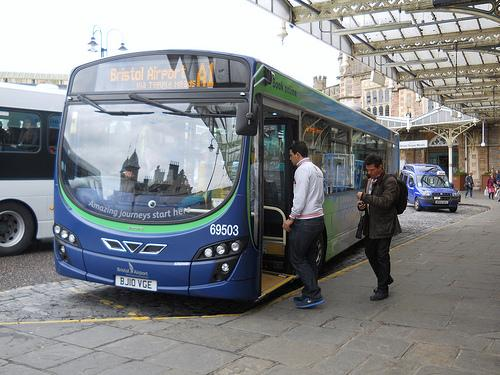Provide an appraisal of the mood or atmosphere portrayed in the image. The image conveys a calm and everyday atmosphere, with the man waiting for the bus and the surrounding environment contributing to a typical city scene. State one specific piece of information related to the bus's destination. The bus is going to the airport. What clothing items can be identified on the man in the image? The man is wearing a brown jacket, blue jeans, white sweater, and sneakers. Describe any infrastructure-related items that can be found in the image. A sidewalk, window of a building, part of a lamp light, and a road are all present in the image. What are the features of the man's sneakers in the image? The man's sneakers are blue and black in color. Express the colors and sizes of the bus shown in the image. The image shows a long blue and green bus. Enumerate any vehicles present behind the bus and their colors. There is a blue car and a blue van behind the bus. Mention a prominent feature found on the bus in the image. The bus has four lights on the front and an open door. What activity does the man seem to be involved in, based on his attire and surrounding environment? The man appears to be waiting for the bus, as he is dressed in a jacket, jeans, and sneakers, and standing near a bus. Are the trees behind the bus green and tall? No trees are described in any of the existing captions. Can you see the yellow bicycle parked next to the bus? None of the captions mention a bicycle or yellow color. Does the man have an umbrella in his hand? No existing caption mentions an umbrella or the man holding anything. Are there people standing inside the open door of the bus? No existing caption mentions people inside the bus or standing near the open door. Is the man wearing a red hat? There is no mention of a hat in any of the existing captions. Is there a large building with a neon sign in the background? There is no information about a building with a neon sign, only a window of a building mentioned. 